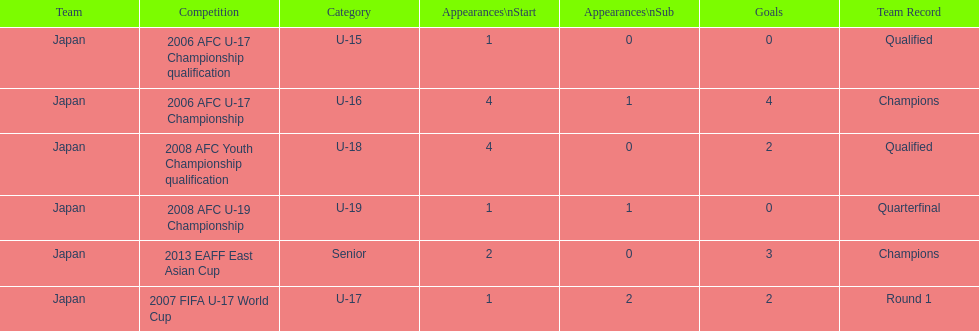What was yoichiro kakitani's first major competition? 2006 AFC U-17 Championship qualification. 